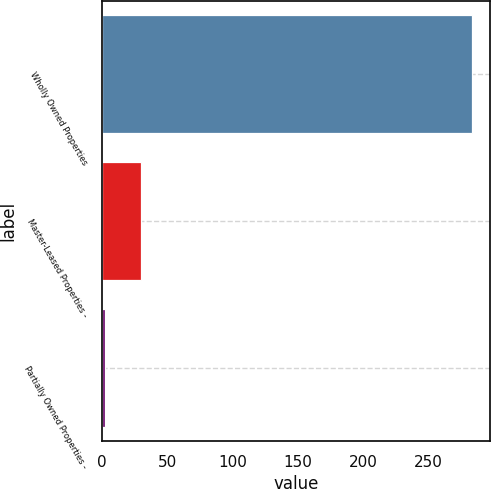Convert chart to OTSL. <chart><loc_0><loc_0><loc_500><loc_500><bar_chart><fcel>Wholly Owned Properties<fcel>Master-Leased Properties -<fcel>Partially Owned Properties -<nl><fcel>283<fcel>30.1<fcel>2<nl></chart> 